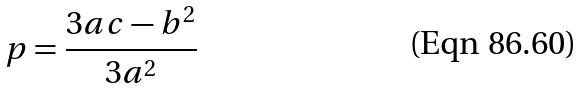Convert formula to latex. <formula><loc_0><loc_0><loc_500><loc_500>p = \frac { 3 a c - b ^ { 2 } } { 3 a ^ { 2 } }</formula> 